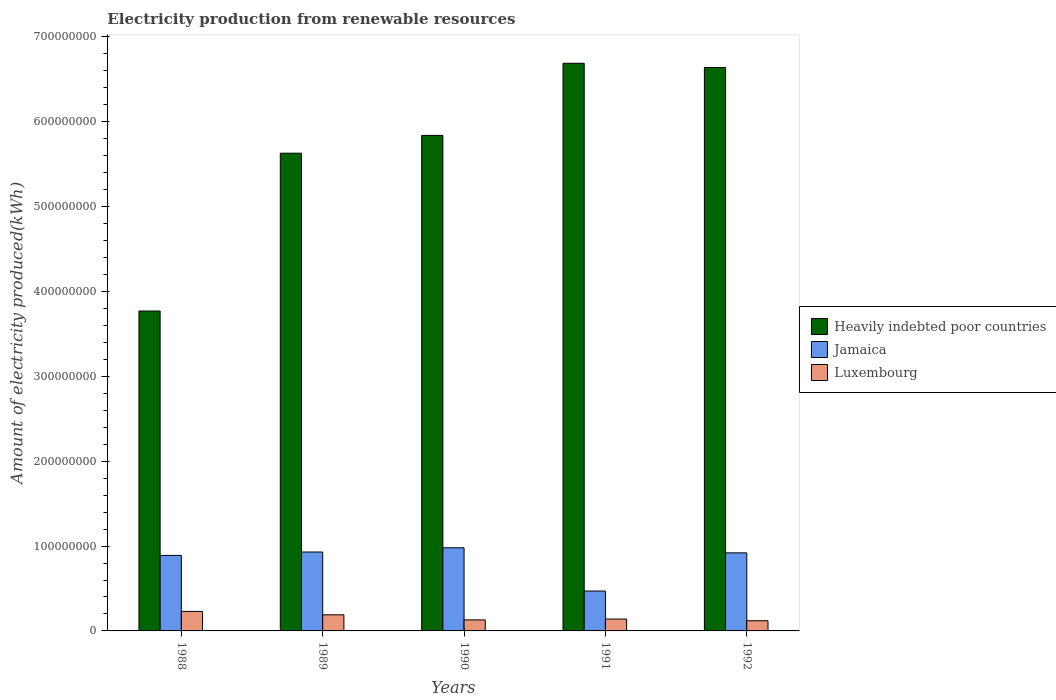How many different coloured bars are there?
Your answer should be very brief. 3. Are the number of bars on each tick of the X-axis equal?
Give a very brief answer. Yes. How many bars are there on the 3rd tick from the left?
Make the answer very short. 3. How many bars are there on the 1st tick from the right?
Make the answer very short. 3. In how many cases, is the number of bars for a given year not equal to the number of legend labels?
Your response must be concise. 0. What is the amount of electricity produced in Heavily indebted poor countries in 1989?
Your answer should be compact. 5.63e+08. Across all years, what is the maximum amount of electricity produced in Heavily indebted poor countries?
Offer a terse response. 6.69e+08. Across all years, what is the minimum amount of electricity produced in Jamaica?
Ensure brevity in your answer.  4.70e+07. In which year was the amount of electricity produced in Heavily indebted poor countries maximum?
Your answer should be compact. 1991. What is the total amount of electricity produced in Luxembourg in the graph?
Your answer should be compact. 8.10e+07. What is the difference between the amount of electricity produced in Heavily indebted poor countries in 1988 and that in 1990?
Ensure brevity in your answer.  -2.07e+08. What is the difference between the amount of electricity produced in Luxembourg in 1992 and the amount of electricity produced in Jamaica in 1991?
Give a very brief answer. -3.50e+07. What is the average amount of electricity produced in Heavily indebted poor countries per year?
Your answer should be compact. 5.71e+08. In the year 1991, what is the difference between the amount of electricity produced in Heavily indebted poor countries and amount of electricity produced in Jamaica?
Provide a succinct answer. 6.22e+08. In how many years, is the amount of electricity produced in Luxembourg greater than 340000000 kWh?
Make the answer very short. 0. What is the ratio of the amount of electricity produced in Jamaica in 1990 to that in 1992?
Your answer should be very brief. 1.07. Is the amount of electricity produced in Luxembourg in 1990 less than that in 1992?
Give a very brief answer. No. What is the difference between the highest and the lowest amount of electricity produced in Jamaica?
Your response must be concise. 5.10e+07. What does the 3rd bar from the left in 1990 represents?
Your answer should be very brief. Luxembourg. What does the 1st bar from the right in 1991 represents?
Give a very brief answer. Luxembourg. Is it the case that in every year, the sum of the amount of electricity produced in Luxembourg and amount of electricity produced in Heavily indebted poor countries is greater than the amount of electricity produced in Jamaica?
Your answer should be very brief. Yes. How many bars are there?
Offer a terse response. 15. Does the graph contain any zero values?
Keep it short and to the point. No. Does the graph contain grids?
Provide a short and direct response. No. How many legend labels are there?
Provide a succinct answer. 3. How are the legend labels stacked?
Make the answer very short. Vertical. What is the title of the graph?
Provide a succinct answer. Electricity production from renewable resources. Does "Gabon" appear as one of the legend labels in the graph?
Offer a very short reply. No. What is the label or title of the X-axis?
Your response must be concise. Years. What is the label or title of the Y-axis?
Keep it short and to the point. Amount of electricity produced(kWh). What is the Amount of electricity produced(kWh) of Heavily indebted poor countries in 1988?
Offer a very short reply. 3.77e+08. What is the Amount of electricity produced(kWh) in Jamaica in 1988?
Ensure brevity in your answer.  8.90e+07. What is the Amount of electricity produced(kWh) in Luxembourg in 1988?
Your answer should be compact. 2.30e+07. What is the Amount of electricity produced(kWh) in Heavily indebted poor countries in 1989?
Your answer should be compact. 5.63e+08. What is the Amount of electricity produced(kWh) of Jamaica in 1989?
Offer a terse response. 9.30e+07. What is the Amount of electricity produced(kWh) of Luxembourg in 1989?
Make the answer very short. 1.90e+07. What is the Amount of electricity produced(kWh) in Heavily indebted poor countries in 1990?
Your answer should be compact. 5.84e+08. What is the Amount of electricity produced(kWh) of Jamaica in 1990?
Offer a terse response. 9.80e+07. What is the Amount of electricity produced(kWh) in Luxembourg in 1990?
Offer a terse response. 1.30e+07. What is the Amount of electricity produced(kWh) of Heavily indebted poor countries in 1991?
Make the answer very short. 6.69e+08. What is the Amount of electricity produced(kWh) in Jamaica in 1991?
Make the answer very short. 4.70e+07. What is the Amount of electricity produced(kWh) in Luxembourg in 1991?
Provide a short and direct response. 1.40e+07. What is the Amount of electricity produced(kWh) in Heavily indebted poor countries in 1992?
Ensure brevity in your answer.  6.64e+08. What is the Amount of electricity produced(kWh) in Jamaica in 1992?
Your response must be concise. 9.20e+07. What is the Amount of electricity produced(kWh) in Luxembourg in 1992?
Provide a short and direct response. 1.20e+07. Across all years, what is the maximum Amount of electricity produced(kWh) in Heavily indebted poor countries?
Offer a very short reply. 6.69e+08. Across all years, what is the maximum Amount of electricity produced(kWh) in Jamaica?
Your answer should be very brief. 9.80e+07. Across all years, what is the maximum Amount of electricity produced(kWh) of Luxembourg?
Provide a short and direct response. 2.30e+07. Across all years, what is the minimum Amount of electricity produced(kWh) in Heavily indebted poor countries?
Your answer should be compact. 3.77e+08. Across all years, what is the minimum Amount of electricity produced(kWh) in Jamaica?
Provide a succinct answer. 4.70e+07. What is the total Amount of electricity produced(kWh) of Heavily indebted poor countries in the graph?
Provide a short and direct response. 2.86e+09. What is the total Amount of electricity produced(kWh) in Jamaica in the graph?
Offer a very short reply. 4.19e+08. What is the total Amount of electricity produced(kWh) of Luxembourg in the graph?
Ensure brevity in your answer.  8.10e+07. What is the difference between the Amount of electricity produced(kWh) of Heavily indebted poor countries in 1988 and that in 1989?
Ensure brevity in your answer.  -1.86e+08. What is the difference between the Amount of electricity produced(kWh) of Jamaica in 1988 and that in 1989?
Your answer should be compact. -4.00e+06. What is the difference between the Amount of electricity produced(kWh) in Luxembourg in 1988 and that in 1989?
Make the answer very short. 4.00e+06. What is the difference between the Amount of electricity produced(kWh) in Heavily indebted poor countries in 1988 and that in 1990?
Keep it short and to the point. -2.07e+08. What is the difference between the Amount of electricity produced(kWh) of Jamaica in 1988 and that in 1990?
Offer a very short reply. -9.00e+06. What is the difference between the Amount of electricity produced(kWh) in Heavily indebted poor countries in 1988 and that in 1991?
Offer a very short reply. -2.92e+08. What is the difference between the Amount of electricity produced(kWh) of Jamaica in 1988 and that in 1991?
Your response must be concise. 4.20e+07. What is the difference between the Amount of electricity produced(kWh) of Luxembourg in 1988 and that in 1991?
Make the answer very short. 9.00e+06. What is the difference between the Amount of electricity produced(kWh) in Heavily indebted poor countries in 1988 and that in 1992?
Your response must be concise. -2.87e+08. What is the difference between the Amount of electricity produced(kWh) of Luxembourg in 1988 and that in 1992?
Your response must be concise. 1.10e+07. What is the difference between the Amount of electricity produced(kWh) in Heavily indebted poor countries in 1989 and that in 1990?
Make the answer very short. -2.10e+07. What is the difference between the Amount of electricity produced(kWh) of Jamaica in 1989 and that in 1990?
Provide a short and direct response. -5.00e+06. What is the difference between the Amount of electricity produced(kWh) in Luxembourg in 1989 and that in 1990?
Keep it short and to the point. 6.00e+06. What is the difference between the Amount of electricity produced(kWh) in Heavily indebted poor countries in 1989 and that in 1991?
Provide a short and direct response. -1.06e+08. What is the difference between the Amount of electricity produced(kWh) of Jamaica in 1989 and that in 1991?
Your answer should be very brief. 4.60e+07. What is the difference between the Amount of electricity produced(kWh) in Luxembourg in 1989 and that in 1991?
Offer a terse response. 5.00e+06. What is the difference between the Amount of electricity produced(kWh) in Heavily indebted poor countries in 1989 and that in 1992?
Provide a succinct answer. -1.01e+08. What is the difference between the Amount of electricity produced(kWh) of Heavily indebted poor countries in 1990 and that in 1991?
Provide a succinct answer. -8.50e+07. What is the difference between the Amount of electricity produced(kWh) in Jamaica in 1990 and that in 1991?
Provide a short and direct response. 5.10e+07. What is the difference between the Amount of electricity produced(kWh) in Heavily indebted poor countries in 1990 and that in 1992?
Ensure brevity in your answer.  -8.00e+07. What is the difference between the Amount of electricity produced(kWh) in Jamaica in 1990 and that in 1992?
Ensure brevity in your answer.  6.00e+06. What is the difference between the Amount of electricity produced(kWh) in Jamaica in 1991 and that in 1992?
Give a very brief answer. -4.50e+07. What is the difference between the Amount of electricity produced(kWh) of Luxembourg in 1991 and that in 1992?
Your answer should be compact. 2.00e+06. What is the difference between the Amount of electricity produced(kWh) in Heavily indebted poor countries in 1988 and the Amount of electricity produced(kWh) in Jamaica in 1989?
Give a very brief answer. 2.84e+08. What is the difference between the Amount of electricity produced(kWh) in Heavily indebted poor countries in 1988 and the Amount of electricity produced(kWh) in Luxembourg in 1989?
Keep it short and to the point. 3.58e+08. What is the difference between the Amount of electricity produced(kWh) in Jamaica in 1988 and the Amount of electricity produced(kWh) in Luxembourg in 1989?
Provide a short and direct response. 7.00e+07. What is the difference between the Amount of electricity produced(kWh) of Heavily indebted poor countries in 1988 and the Amount of electricity produced(kWh) of Jamaica in 1990?
Give a very brief answer. 2.79e+08. What is the difference between the Amount of electricity produced(kWh) in Heavily indebted poor countries in 1988 and the Amount of electricity produced(kWh) in Luxembourg in 1990?
Make the answer very short. 3.64e+08. What is the difference between the Amount of electricity produced(kWh) of Jamaica in 1988 and the Amount of electricity produced(kWh) of Luxembourg in 1990?
Make the answer very short. 7.60e+07. What is the difference between the Amount of electricity produced(kWh) in Heavily indebted poor countries in 1988 and the Amount of electricity produced(kWh) in Jamaica in 1991?
Ensure brevity in your answer.  3.30e+08. What is the difference between the Amount of electricity produced(kWh) in Heavily indebted poor countries in 1988 and the Amount of electricity produced(kWh) in Luxembourg in 1991?
Offer a very short reply. 3.63e+08. What is the difference between the Amount of electricity produced(kWh) in Jamaica in 1988 and the Amount of electricity produced(kWh) in Luxembourg in 1991?
Offer a very short reply. 7.50e+07. What is the difference between the Amount of electricity produced(kWh) in Heavily indebted poor countries in 1988 and the Amount of electricity produced(kWh) in Jamaica in 1992?
Ensure brevity in your answer.  2.85e+08. What is the difference between the Amount of electricity produced(kWh) of Heavily indebted poor countries in 1988 and the Amount of electricity produced(kWh) of Luxembourg in 1992?
Your response must be concise. 3.65e+08. What is the difference between the Amount of electricity produced(kWh) in Jamaica in 1988 and the Amount of electricity produced(kWh) in Luxembourg in 1992?
Your answer should be compact. 7.70e+07. What is the difference between the Amount of electricity produced(kWh) of Heavily indebted poor countries in 1989 and the Amount of electricity produced(kWh) of Jamaica in 1990?
Offer a terse response. 4.65e+08. What is the difference between the Amount of electricity produced(kWh) in Heavily indebted poor countries in 1989 and the Amount of electricity produced(kWh) in Luxembourg in 1990?
Your answer should be compact. 5.50e+08. What is the difference between the Amount of electricity produced(kWh) of Jamaica in 1989 and the Amount of electricity produced(kWh) of Luxembourg in 1990?
Give a very brief answer. 8.00e+07. What is the difference between the Amount of electricity produced(kWh) of Heavily indebted poor countries in 1989 and the Amount of electricity produced(kWh) of Jamaica in 1991?
Provide a succinct answer. 5.16e+08. What is the difference between the Amount of electricity produced(kWh) in Heavily indebted poor countries in 1989 and the Amount of electricity produced(kWh) in Luxembourg in 1991?
Keep it short and to the point. 5.49e+08. What is the difference between the Amount of electricity produced(kWh) in Jamaica in 1989 and the Amount of electricity produced(kWh) in Luxembourg in 1991?
Give a very brief answer. 7.90e+07. What is the difference between the Amount of electricity produced(kWh) in Heavily indebted poor countries in 1989 and the Amount of electricity produced(kWh) in Jamaica in 1992?
Provide a succinct answer. 4.71e+08. What is the difference between the Amount of electricity produced(kWh) in Heavily indebted poor countries in 1989 and the Amount of electricity produced(kWh) in Luxembourg in 1992?
Your answer should be compact. 5.51e+08. What is the difference between the Amount of electricity produced(kWh) of Jamaica in 1989 and the Amount of electricity produced(kWh) of Luxembourg in 1992?
Your answer should be very brief. 8.10e+07. What is the difference between the Amount of electricity produced(kWh) of Heavily indebted poor countries in 1990 and the Amount of electricity produced(kWh) of Jamaica in 1991?
Provide a succinct answer. 5.37e+08. What is the difference between the Amount of electricity produced(kWh) of Heavily indebted poor countries in 1990 and the Amount of electricity produced(kWh) of Luxembourg in 1991?
Provide a succinct answer. 5.70e+08. What is the difference between the Amount of electricity produced(kWh) of Jamaica in 1990 and the Amount of electricity produced(kWh) of Luxembourg in 1991?
Give a very brief answer. 8.40e+07. What is the difference between the Amount of electricity produced(kWh) in Heavily indebted poor countries in 1990 and the Amount of electricity produced(kWh) in Jamaica in 1992?
Keep it short and to the point. 4.92e+08. What is the difference between the Amount of electricity produced(kWh) in Heavily indebted poor countries in 1990 and the Amount of electricity produced(kWh) in Luxembourg in 1992?
Provide a short and direct response. 5.72e+08. What is the difference between the Amount of electricity produced(kWh) in Jamaica in 1990 and the Amount of electricity produced(kWh) in Luxembourg in 1992?
Provide a succinct answer. 8.60e+07. What is the difference between the Amount of electricity produced(kWh) in Heavily indebted poor countries in 1991 and the Amount of electricity produced(kWh) in Jamaica in 1992?
Your answer should be very brief. 5.77e+08. What is the difference between the Amount of electricity produced(kWh) of Heavily indebted poor countries in 1991 and the Amount of electricity produced(kWh) of Luxembourg in 1992?
Make the answer very short. 6.57e+08. What is the difference between the Amount of electricity produced(kWh) of Jamaica in 1991 and the Amount of electricity produced(kWh) of Luxembourg in 1992?
Give a very brief answer. 3.50e+07. What is the average Amount of electricity produced(kWh) of Heavily indebted poor countries per year?
Ensure brevity in your answer.  5.71e+08. What is the average Amount of electricity produced(kWh) of Jamaica per year?
Keep it short and to the point. 8.38e+07. What is the average Amount of electricity produced(kWh) of Luxembourg per year?
Provide a short and direct response. 1.62e+07. In the year 1988, what is the difference between the Amount of electricity produced(kWh) in Heavily indebted poor countries and Amount of electricity produced(kWh) in Jamaica?
Ensure brevity in your answer.  2.88e+08. In the year 1988, what is the difference between the Amount of electricity produced(kWh) of Heavily indebted poor countries and Amount of electricity produced(kWh) of Luxembourg?
Offer a terse response. 3.54e+08. In the year 1988, what is the difference between the Amount of electricity produced(kWh) of Jamaica and Amount of electricity produced(kWh) of Luxembourg?
Ensure brevity in your answer.  6.60e+07. In the year 1989, what is the difference between the Amount of electricity produced(kWh) of Heavily indebted poor countries and Amount of electricity produced(kWh) of Jamaica?
Provide a succinct answer. 4.70e+08. In the year 1989, what is the difference between the Amount of electricity produced(kWh) of Heavily indebted poor countries and Amount of electricity produced(kWh) of Luxembourg?
Make the answer very short. 5.44e+08. In the year 1989, what is the difference between the Amount of electricity produced(kWh) in Jamaica and Amount of electricity produced(kWh) in Luxembourg?
Make the answer very short. 7.40e+07. In the year 1990, what is the difference between the Amount of electricity produced(kWh) in Heavily indebted poor countries and Amount of electricity produced(kWh) in Jamaica?
Your response must be concise. 4.86e+08. In the year 1990, what is the difference between the Amount of electricity produced(kWh) in Heavily indebted poor countries and Amount of electricity produced(kWh) in Luxembourg?
Provide a short and direct response. 5.71e+08. In the year 1990, what is the difference between the Amount of electricity produced(kWh) in Jamaica and Amount of electricity produced(kWh) in Luxembourg?
Offer a terse response. 8.50e+07. In the year 1991, what is the difference between the Amount of electricity produced(kWh) in Heavily indebted poor countries and Amount of electricity produced(kWh) in Jamaica?
Offer a very short reply. 6.22e+08. In the year 1991, what is the difference between the Amount of electricity produced(kWh) of Heavily indebted poor countries and Amount of electricity produced(kWh) of Luxembourg?
Ensure brevity in your answer.  6.55e+08. In the year 1991, what is the difference between the Amount of electricity produced(kWh) in Jamaica and Amount of electricity produced(kWh) in Luxembourg?
Make the answer very short. 3.30e+07. In the year 1992, what is the difference between the Amount of electricity produced(kWh) in Heavily indebted poor countries and Amount of electricity produced(kWh) in Jamaica?
Provide a short and direct response. 5.72e+08. In the year 1992, what is the difference between the Amount of electricity produced(kWh) of Heavily indebted poor countries and Amount of electricity produced(kWh) of Luxembourg?
Provide a short and direct response. 6.52e+08. In the year 1992, what is the difference between the Amount of electricity produced(kWh) of Jamaica and Amount of electricity produced(kWh) of Luxembourg?
Keep it short and to the point. 8.00e+07. What is the ratio of the Amount of electricity produced(kWh) of Heavily indebted poor countries in 1988 to that in 1989?
Your answer should be very brief. 0.67. What is the ratio of the Amount of electricity produced(kWh) in Jamaica in 1988 to that in 1989?
Offer a terse response. 0.96. What is the ratio of the Amount of electricity produced(kWh) of Luxembourg in 1988 to that in 1989?
Give a very brief answer. 1.21. What is the ratio of the Amount of electricity produced(kWh) in Heavily indebted poor countries in 1988 to that in 1990?
Ensure brevity in your answer.  0.65. What is the ratio of the Amount of electricity produced(kWh) of Jamaica in 1988 to that in 1990?
Your response must be concise. 0.91. What is the ratio of the Amount of electricity produced(kWh) of Luxembourg in 1988 to that in 1990?
Ensure brevity in your answer.  1.77. What is the ratio of the Amount of electricity produced(kWh) in Heavily indebted poor countries in 1988 to that in 1991?
Offer a very short reply. 0.56. What is the ratio of the Amount of electricity produced(kWh) in Jamaica in 1988 to that in 1991?
Provide a succinct answer. 1.89. What is the ratio of the Amount of electricity produced(kWh) in Luxembourg in 1988 to that in 1991?
Your answer should be compact. 1.64. What is the ratio of the Amount of electricity produced(kWh) of Heavily indebted poor countries in 1988 to that in 1992?
Offer a very short reply. 0.57. What is the ratio of the Amount of electricity produced(kWh) of Jamaica in 1988 to that in 1992?
Offer a terse response. 0.97. What is the ratio of the Amount of electricity produced(kWh) in Luxembourg in 1988 to that in 1992?
Your response must be concise. 1.92. What is the ratio of the Amount of electricity produced(kWh) in Jamaica in 1989 to that in 1990?
Offer a very short reply. 0.95. What is the ratio of the Amount of electricity produced(kWh) in Luxembourg in 1989 to that in 1990?
Make the answer very short. 1.46. What is the ratio of the Amount of electricity produced(kWh) in Heavily indebted poor countries in 1989 to that in 1991?
Your response must be concise. 0.84. What is the ratio of the Amount of electricity produced(kWh) of Jamaica in 1989 to that in 1991?
Provide a succinct answer. 1.98. What is the ratio of the Amount of electricity produced(kWh) in Luxembourg in 1989 to that in 1991?
Offer a very short reply. 1.36. What is the ratio of the Amount of electricity produced(kWh) in Heavily indebted poor countries in 1989 to that in 1992?
Keep it short and to the point. 0.85. What is the ratio of the Amount of electricity produced(kWh) of Jamaica in 1989 to that in 1992?
Your answer should be compact. 1.01. What is the ratio of the Amount of electricity produced(kWh) in Luxembourg in 1989 to that in 1992?
Offer a terse response. 1.58. What is the ratio of the Amount of electricity produced(kWh) of Heavily indebted poor countries in 1990 to that in 1991?
Provide a short and direct response. 0.87. What is the ratio of the Amount of electricity produced(kWh) of Jamaica in 1990 to that in 1991?
Your response must be concise. 2.09. What is the ratio of the Amount of electricity produced(kWh) in Luxembourg in 1990 to that in 1991?
Provide a short and direct response. 0.93. What is the ratio of the Amount of electricity produced(kWh) of Heavily indebted poor countries in 1990 to that in 1992?
Give a very brief answer. 0.88. What is the ratio of the Amount of electricity produced(kWh) in Jamaica in 1990 to that in 1992?
Make the answer very short. 1.07. What is the ratio of the Amount of electricity produced(kWh) in Heavily indebted poor countries in 1991 to that in 1992?
Provide a short and direct response. 1.01. What is the ratio of the Amount of electricity produced(kWh) of Jamaica in 1991 to that in 1992?
Offer a terse response. 0.51. What is the ratio of the Amount of electricity produced(kWh) of Luxembourg in 1991 to that in 1992?
Give a very brief answer. 1.17. What is the difference between the highest and the second highest Amount of electricity produced(kWh) in Heavily indebted poor countries?
Make the answer very short. 5.00e+06. What is the difference between the highest and the lowest Amount of electricity produced(kWh) of Heavily indebted poor countries?
Offer a terse response. 2.92e+08. What is the difference between the highest and the lowest Amount of electricity produced(kWh) of Jamaica?
Provide a succinct answer. 5.10e+07. What is the difference between the highest and the lowest Amount of electricity produced(kWh) in Luxembourg?
Offer a very short reply. 1.10e+07. 